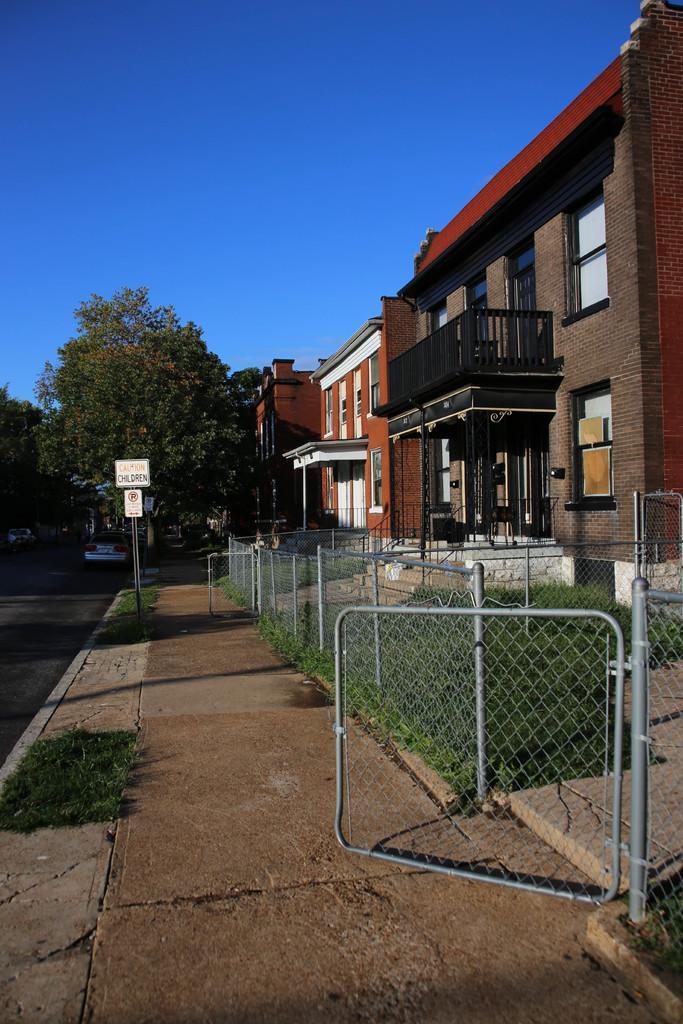In one or two sentences, can you explain what this image depicts? In this image we can see buildings with windows, fence, trees, plants, board and we can also see the sky. 